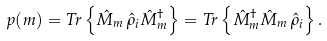Convert formula to latex. <formula><loc_0><loc_0><loc_500><loc_500>p ( m ) = T r \left \{ \hat { M } _ { m } \, \hat { \rho } _ { i } \hat { M } _ { m } ^ { \dagger } \right \} = T r \left \{ \hat { M } _ { m } ^ { \dagger } \hat { M } _ { m } \, \hat { \rho } _ { i } \right \} .</formula> 